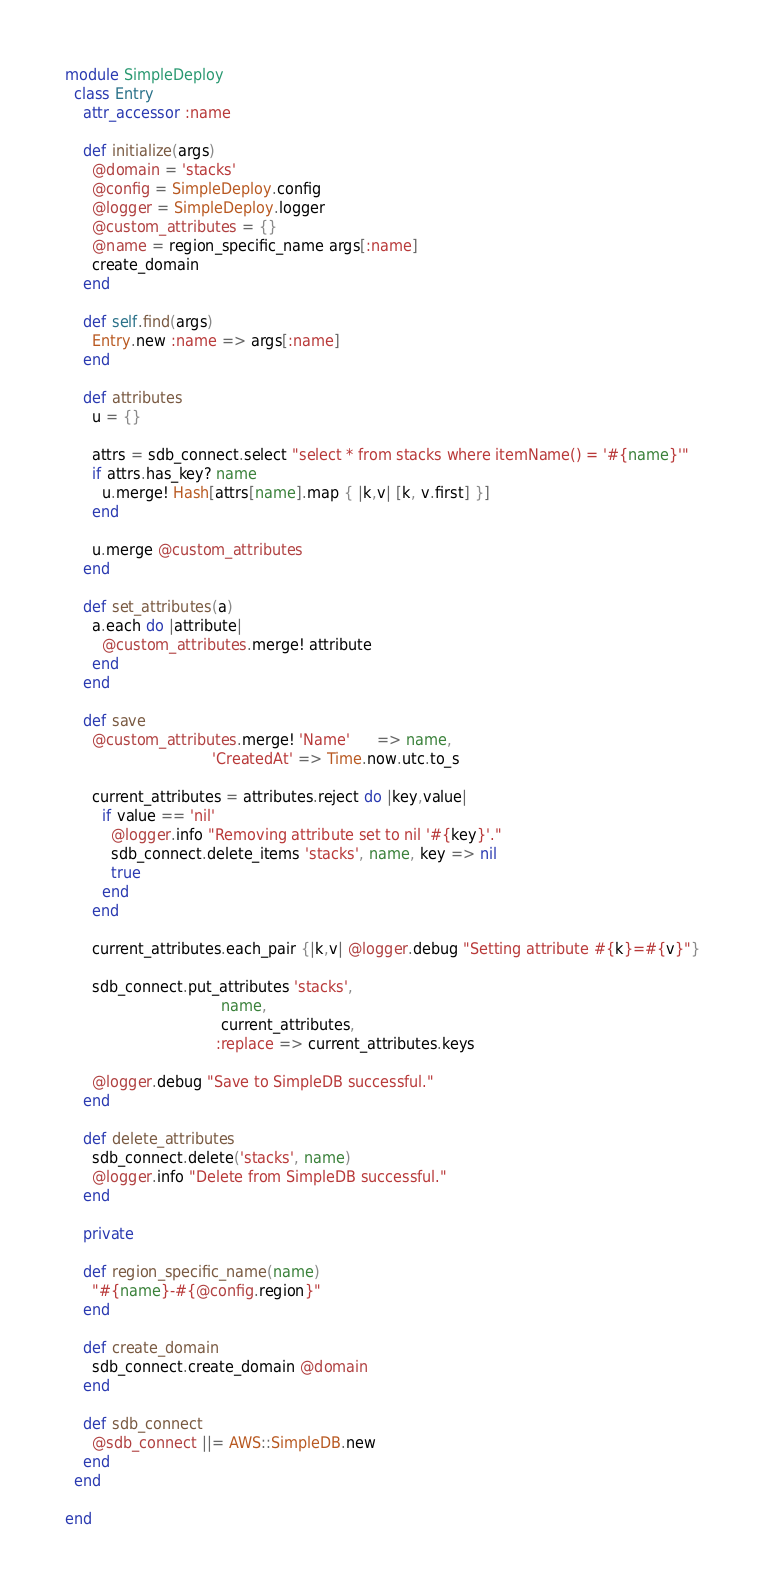Convert code to text. <code><loc_0><loc_0><loc_500><loc_500><_Ruby_>
module SimpleDeploy
  class Entry
    attr_accessor :name

    def initialize(args)
      @domain = 'stacks'
      @config = SimpleDeploy.config
      @logger = SimpleDeploy.logger
      @custom_attributes = {}
      @name = region_specific_name args[:name]
      create_domain
    end

    def self.find(args)
      Entry.new :name => args[:name]
    end

    def attributes
      u = {}

      attrs = sdb_connect.select "select * from stacks where itemName() = '#{name}'"
      if attrs.has_key? name
        u.merge! Hash[attrs[name].map { |k,v| [k, v.first] }]
      end

      u.merge @custom_attributes
    end

    def set_attributes(a)
      a.each do |attribute|
        @custom_attributes.merge! attribute
      end
    end

    def save
      @custom_attributes.merge! 'Name'      => name,
                                'CreatedAt' => Time.now.utc.to_s

      current_attributes = attributes.reject do |key,value|
        if value == 'nil'
          @logger.info "Removing attribute set to nil '#{key}'."
          sdb_connect.delete_items 'stacks', name, key => nil
          true
        end
      end

      current_attributes.each_pair {|k,v| @logger.debug "Setting attribute #{k}=#{v}"}

      sdb_connect.put_attributes 'stacks',
                                  name,
                                  current_attributes,
                                 :replace => current_attributes.keys

      @logger.debug "Save to SimpleDB successful." 
    end
 
    def delete_attributes
      sdb_connect.delete('stacks', name)
      @logger.info "Delete from SimpleDB successful."
    end

    private

    def region_specific_name(name)
      "#{name}-#{@config.region}"
    end

    def create_domain
      sdb_connect.create_domain @domain
    end

    def sdb_connect
      @sdb_connect ||= AWS::SimpleDB.new
    end
  end

end
</code> 